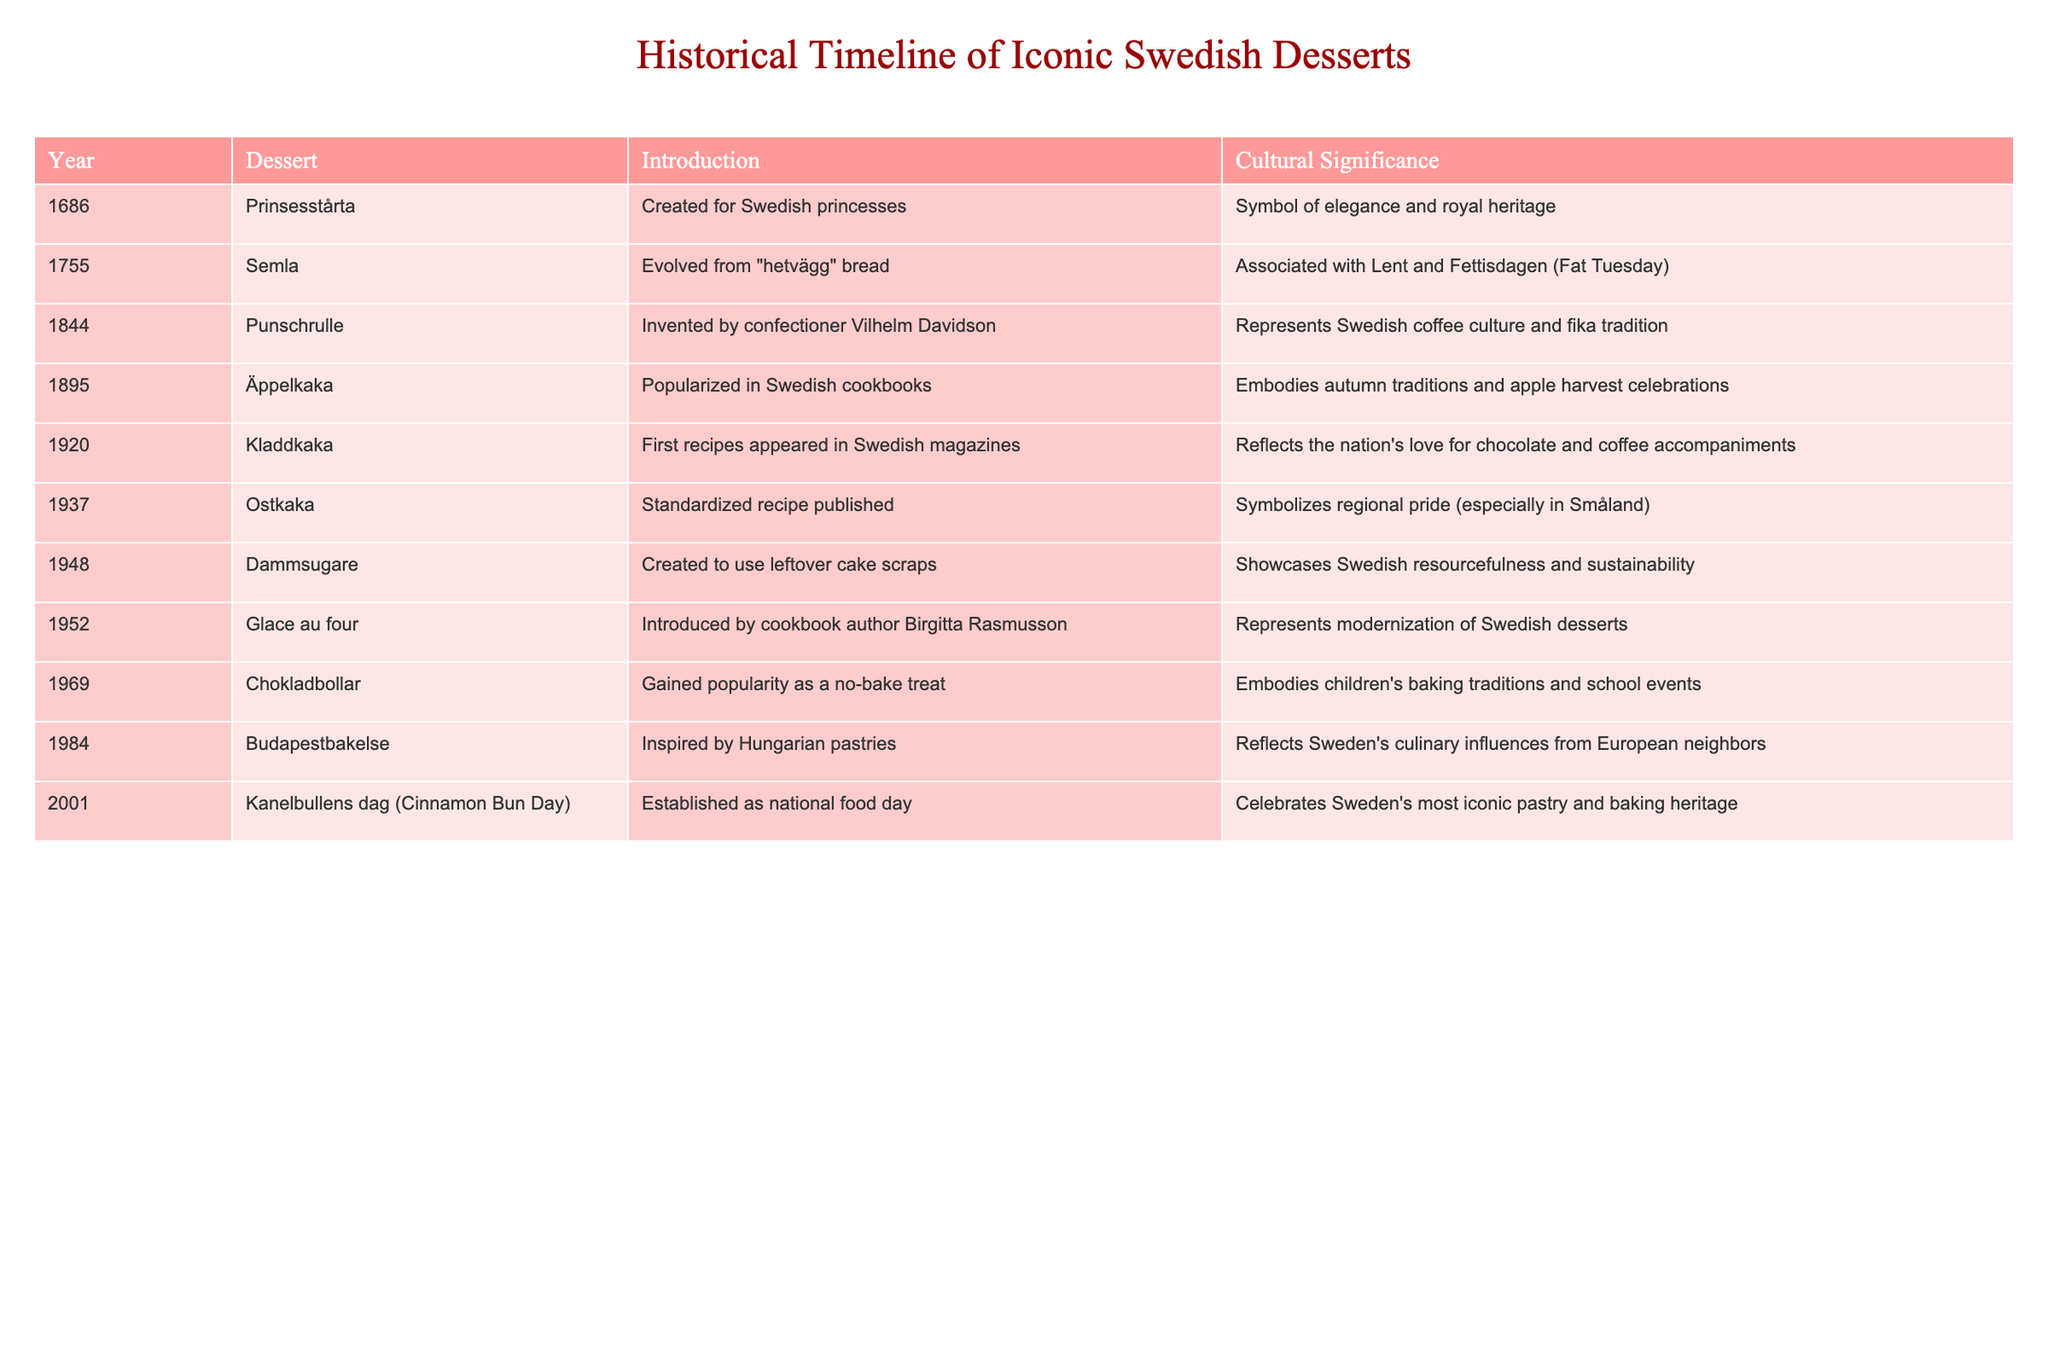What year was Semla introduced? According to the table, Semla was introduced in the year 1755.
Answer: 1755 What dessert was created for Swedish princesses? The table states that Prinsesstårta was created for Swedish princesses.
Answer: Prinsesstårta What cultural significance is associated with Kladdkaka? The table reveals that Kladdkaka reflects the nation's love for chocolate and coffee accompaniments.
Answer: Love for chocolate and coffee What dessert represents Swedish resourcefulness and sustainability? Based on the table, the dessert that represents Swedish resourcefulness and sustainability is Dammsugare, created in 1948.
Answer: Dammsugare Which two desserts have an introduction year in the 1900s? From the table, the desserts introduced in the 1900s are Äppelkaka (1895) and Ostkaka (1937).
Answer: Äppelkaka and Ostkaka How many desserts were introduced before the year 1900? Counting the desserts listed in the table, there are five introduced before 1900: Prinsesstårta, Semla, Punschrulle, Äppelkaka, and Kladdkaka.
Answer: 5 Is Kanelbullens dag established as a national food day? The table indicates that Kanelbullens dag was established as a national food day in 2001, which confirms it.
Answer: Yes What dessert first appeared in Swedish magazines in 1920? The table shows that Kladdkaka was the dessert that first appeared in Swedish magazines in 1920.
Answer: Kladdkaka Which dessert has the most recent introduction year? By examining the table, the most recent dessert introduced is Kanelbullens dag in 2001.
Answer: Kanelbullens dag What is the overall cultural significance of Punschrulle? According to the table, Punschrulle represents Swedish coffee culture and the fika tradition.
Answer: Coffee culture and fika tradition Which dessert represents autumn traditions and apple harvest celebrations? The table specifies that Äppelkaka embodies autumn traditions and apple harvest celebrations.
Answer: Äppelkaka How many desserts were introduced after 1950? The table shows that three desserts were introduced after 1950: Glace au four (1952), Chokladbollar (1969), and Kanelbullens dag (2001).
Answer: 3 What is the common theme of desserts introduced in the 20th century? The table indicates that many of the desserts introduced in the 20th century reflect modernization, new culinary influences, and cultural celebrations in Sweden.
Answer: Modernization and cultural celebrations 